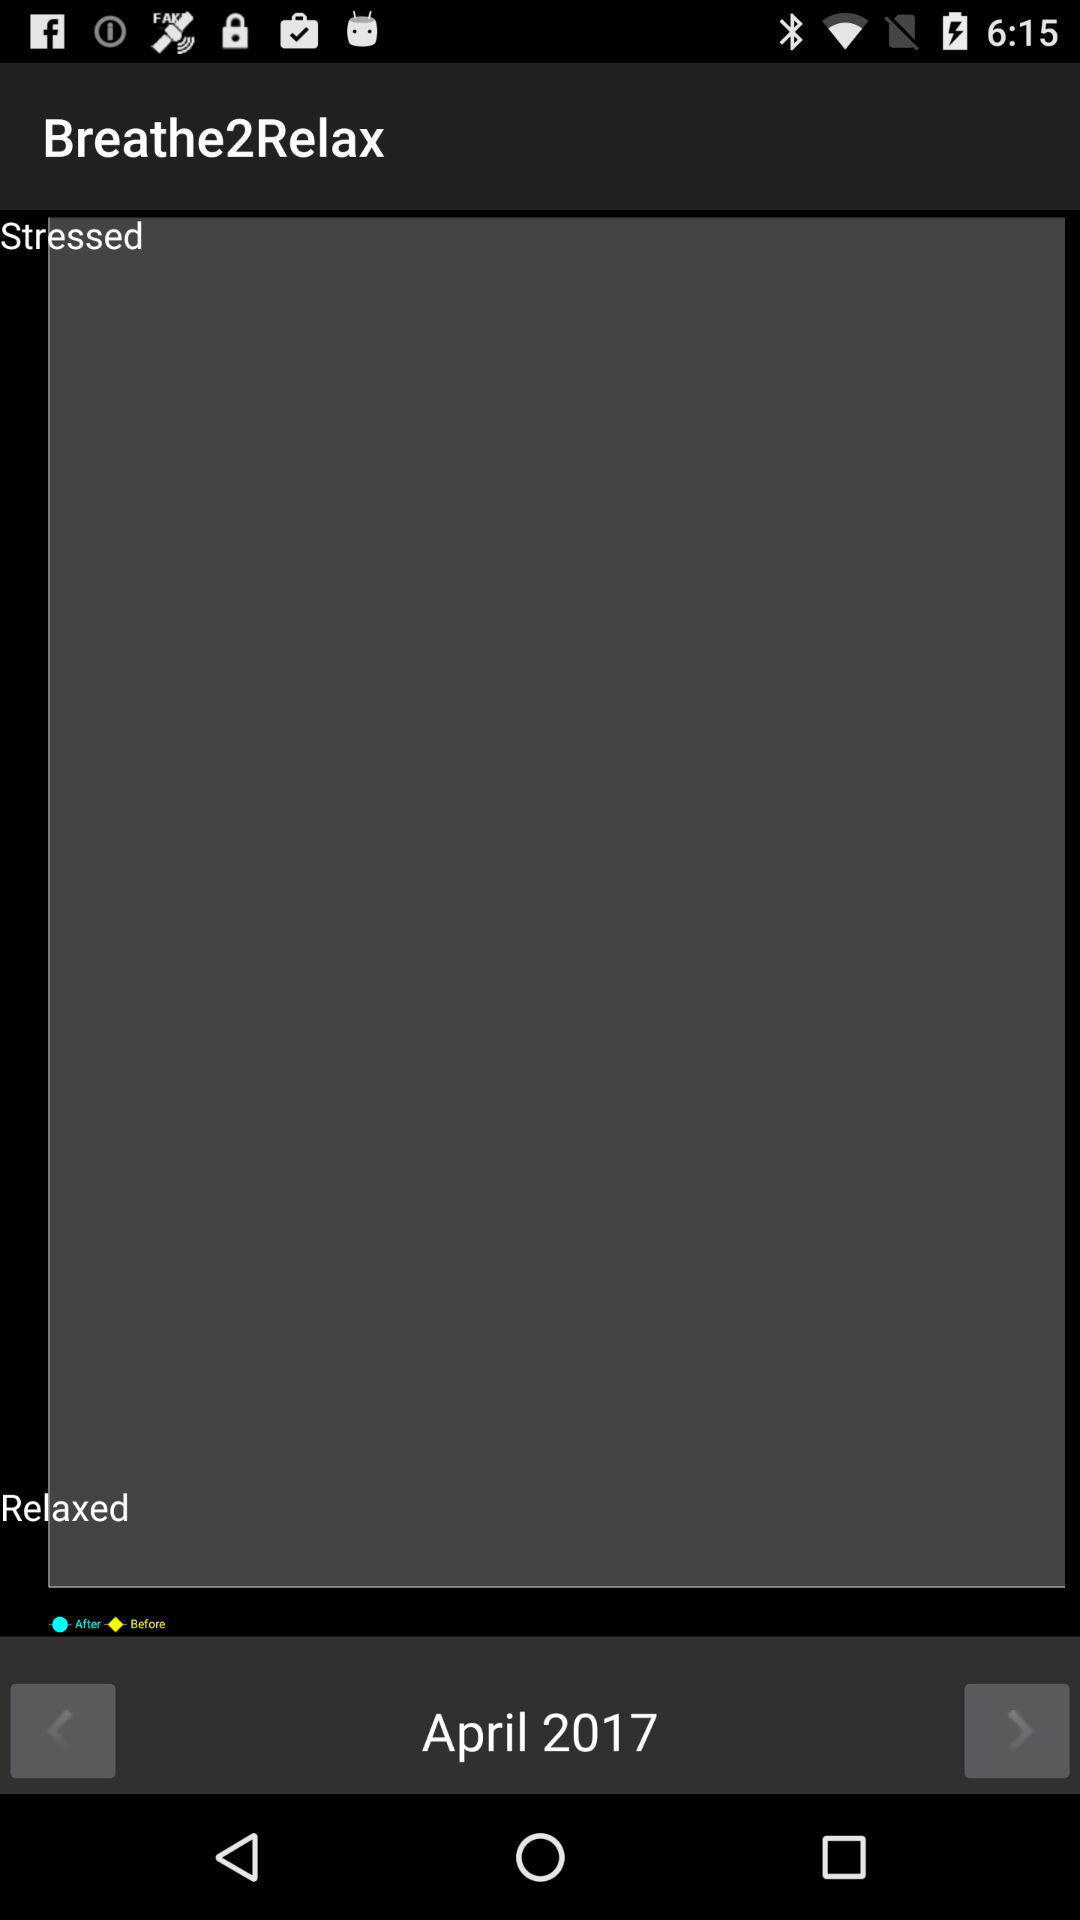When was "Breathe2Relax" copyrighted?
When the provided information is insufficient, respond with <no answer>. <no answer> 